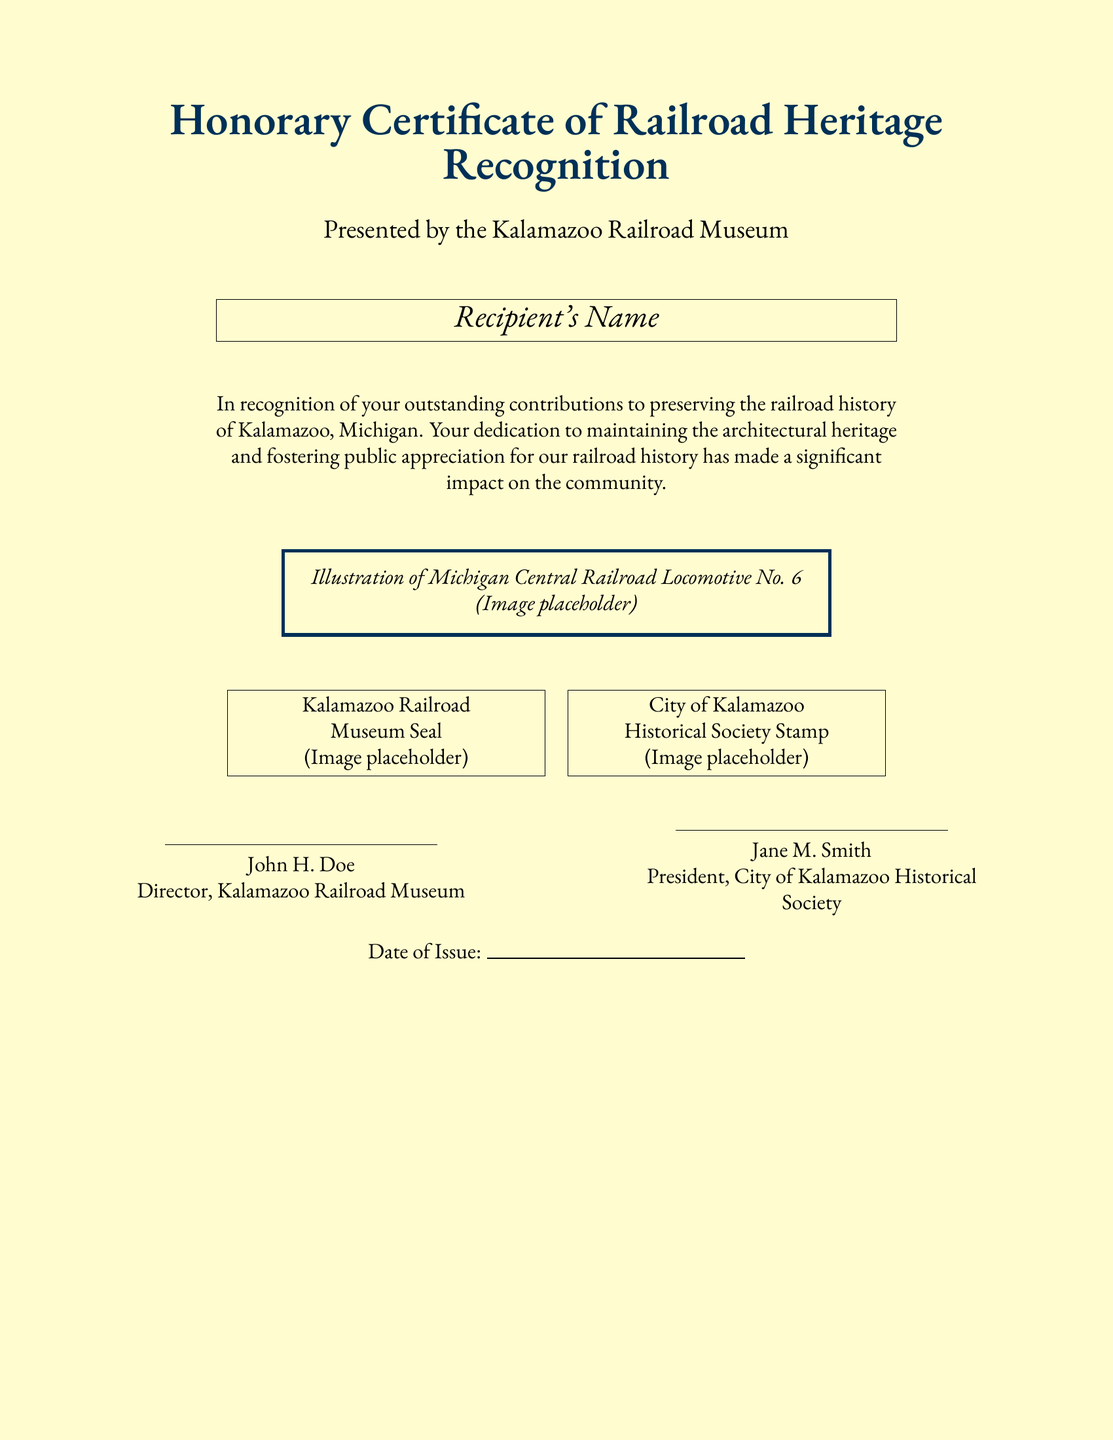What is the title of the certificate? The title is prominently displayed at the top of the document and is “Honorary Certificate of Railroad Heritage Recognition.”
Answer: Honorary Certificate of Railroad Heritage Recognition Who presented the certificate? The presenting organization is mentioned directly below the title, indicating the authority behind the certificate issuance.
Answer: Kalamazoo Railroad Museum What does the certificate recognize? The text specifies the purpose of the certificate, highlighting contributions to a specific aspect of local heritage.
Answer: Preserving the railroad history of Kalamazoo What is the name of the locomotive illustrated? The illustration description references a specific locomotive that holds historical significance in Michigan.
Answer: Michigan Central Railroad Locomotive No. 6 Who is the director of the Kalamazoo Railroad Museum? The document includes signatures, which provide official names responsible for the certificate's issuance.
Answer: John H. Doe What is the date of issue represented as? There is a placeholder for the date, denoted clearly in the document.
Answer: (Blank for date) What are the two seals/stamps featured on the certificate? The document mentions specific seals that add authenticity to the certificate.
Answer: Kalamazoo Railroad Museum Seal, City of Kalamazoo Historical Society Stamp Who is the president of the City of Kalamazoo Historical Society? The document includes the name under the printed signature affirming the certificate's authority from the historical society.
Answer: Jane M. Smith 